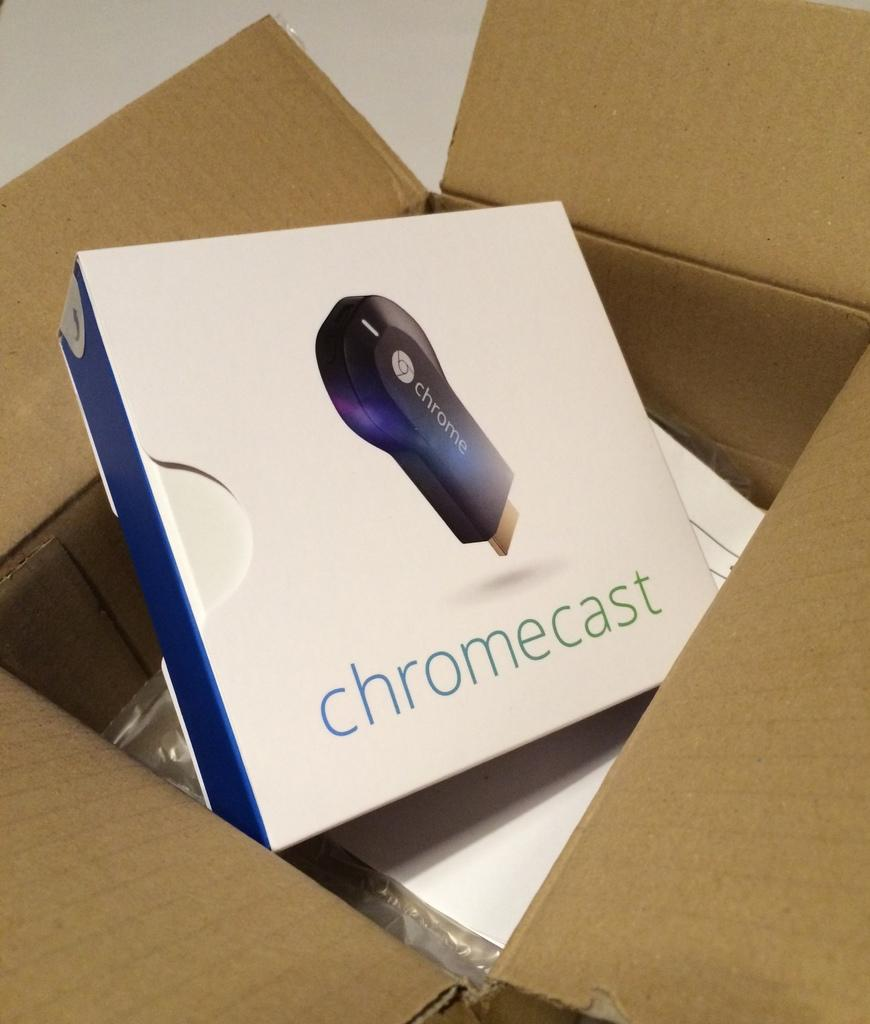<image>
Create a compact narrative representing the image presented. A white Chromecast box sits inside a larger cardboard box. 